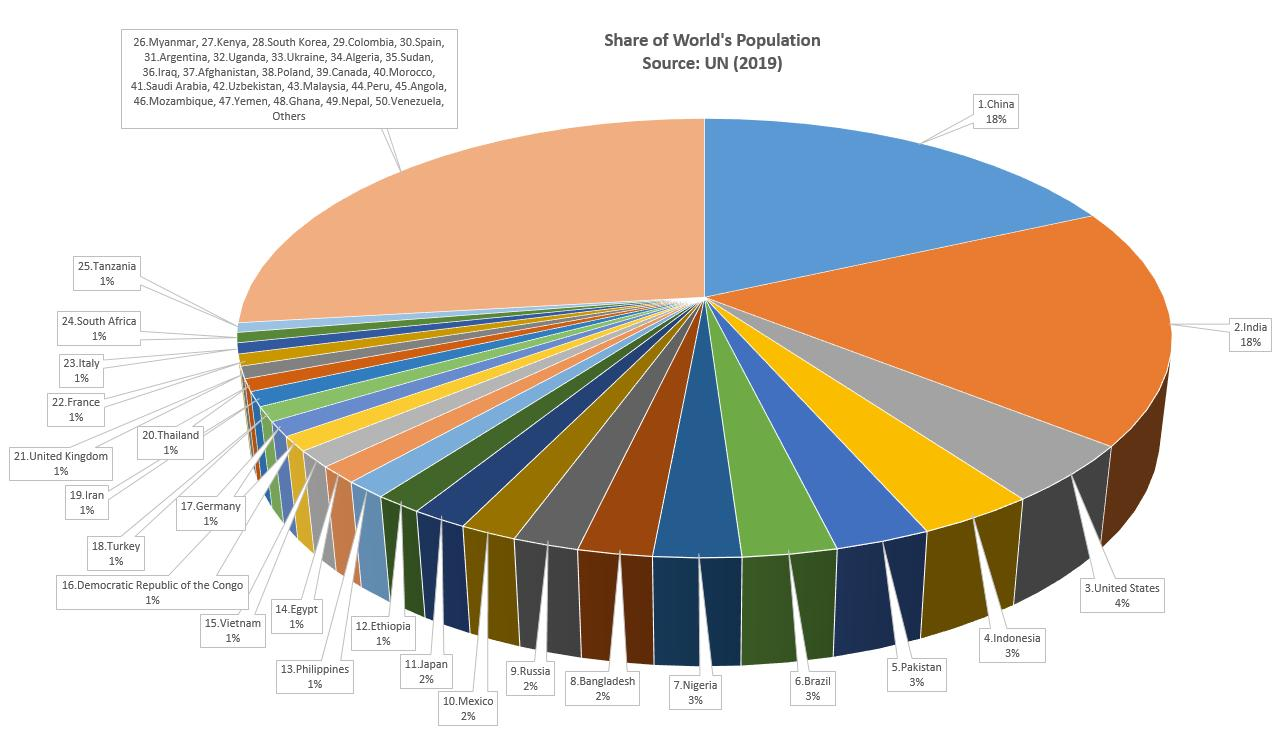Highlight a few significant elements in this photo. Four countries, representing only 2% of the world's population, have been identified. Four countries, representing 3% of the world's population, have been identified. Approximately 170 nations contribute to the remaining share of the world population in the 'Others' category. It is reported that China and India share the highest population percentage in the world. The population gap between India and the United States is 14%. 